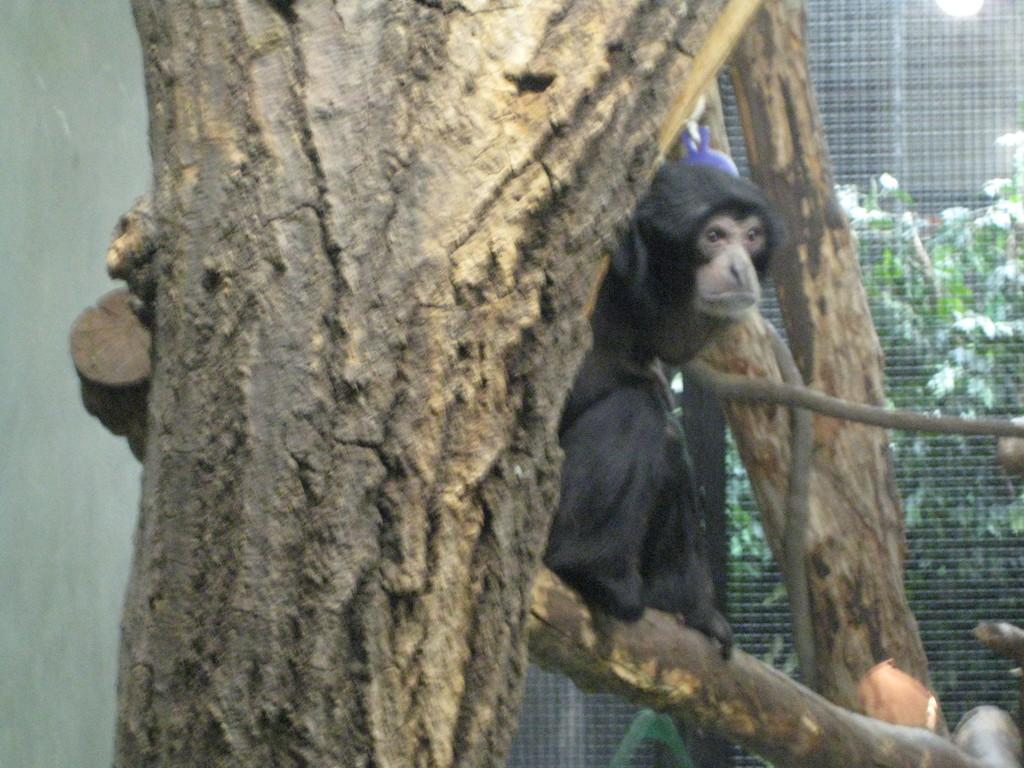What is the animal sitting on in the image? The animal is sitting on a branch in the image. What else can be seen in the image besides the animal? There are tree trunks, a wall, and a mesh visible in the image. What is behind the mesh in the image? There are plants visible behind the mesh. Can you describe the lighting in the image? There is light in the image. What type of fruit is the animal holding in its hand in the image? There is no fruit visible in the image, and the animal is not holding anything in its hand. 